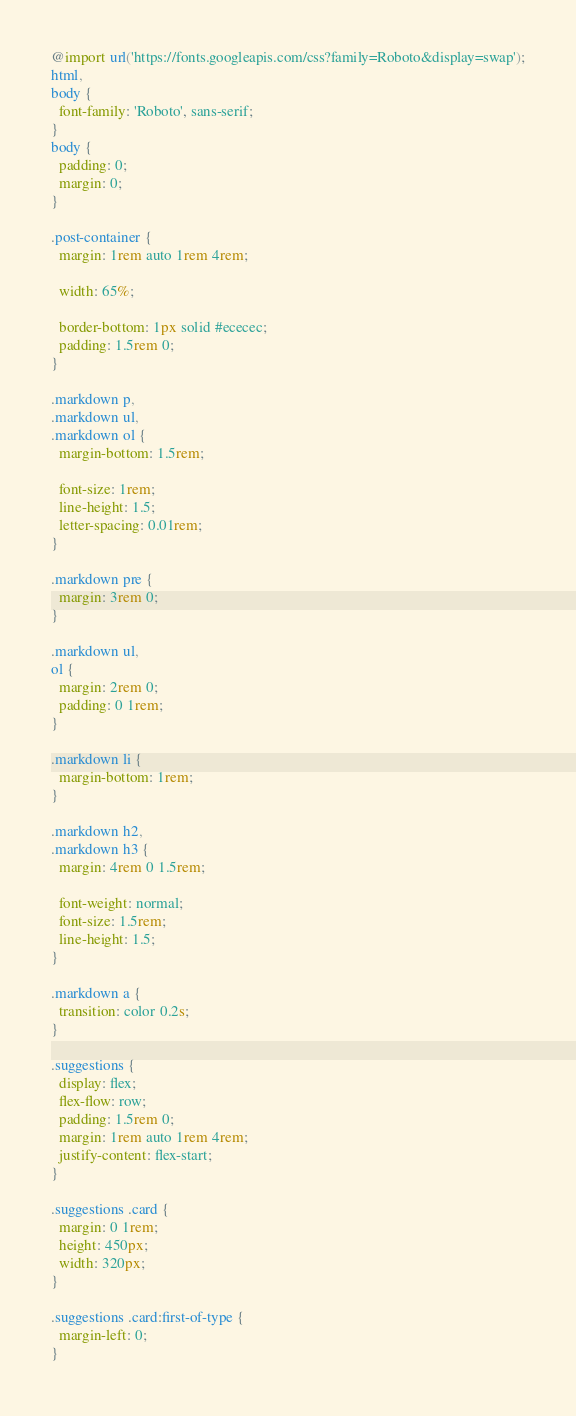Convert code to text. <code><loc_0><loc_0><loc_500><loc_500><_CSS_>@import url('https://fonts.googleapis.com/css?family=Roboto&display=swap');
html,
body {
  font-family: 'Roboto', sans-serif;
}
body {
  padding: 0;
  margin: 0;
}

.post-container {
  margin: 1rem auto 1rem 4rem;

  width: 65%;

  border-bottom: 1px solid #ececec;
  padding: 1.5rem 0;
}

.markdown p,
.markdown ul,
.markdown ol {
  margin-bottom: 1.5rem;

  font-size: 1rem;
  line-height: 1.5;
  letter-spacing: 0.01rem;
}

.markdown pre {
  margin: 3rem 0;
}

.markdown ul,
ol {
  margin: 2rem 0;
  padding: 0 1rem;
}

.markdown li {
  margin-bottom: 1rem;
}

.markdown h2,
.markdown h3 {
  margin: 4rem 0 1.5rem;

  font-weight: normal;
  font-size: 1.5rem;
  line-height: 1.5;
}

.markdown a {
  transition: color 0.2s;
}

.suggestions {
  display: flex;
  flex-flow: row;
  padding: 1.5rem 0;
  margin: 1rem auto 1rem 4rem;
  justify-content: flex-start;
}

.suggestions .card {
  margin: 0 1rem;
  height: 450px;
  width: 320px;
}

.suggestions .card:first-of-type {
  margin-left: 0;
}

</code> 